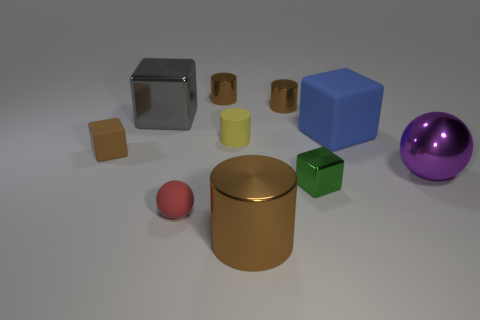Describe the atmosphere or mood that this arrangement of objects could represent. The arrangement of the objects appears to be orderly and structured, possibly representing organization and clarity of thought. The variety and simplicity of the shapes could suggest a theme of diversity in unity or the beauty of basic geometric forms. 